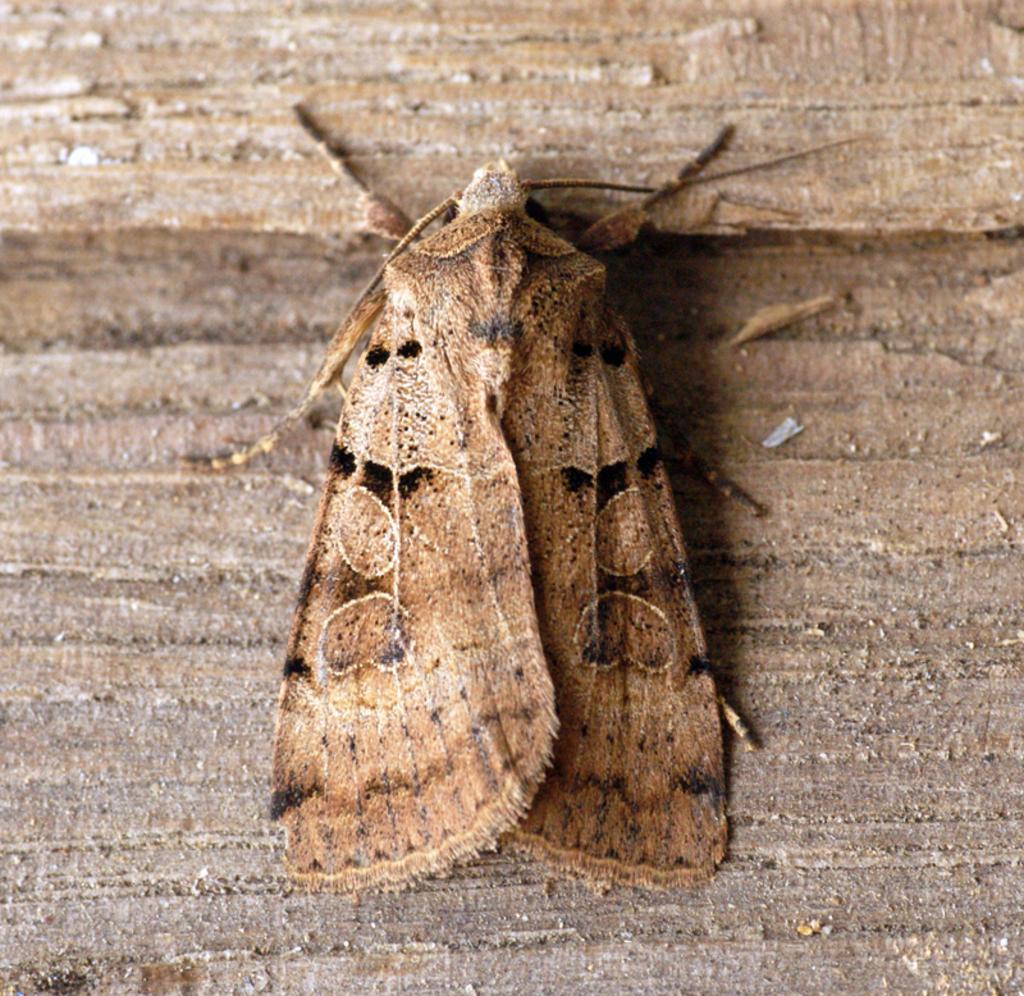Could you give a brief overview of what you see in this image? In the center of the image, we can see a fly on the wooden surface. 